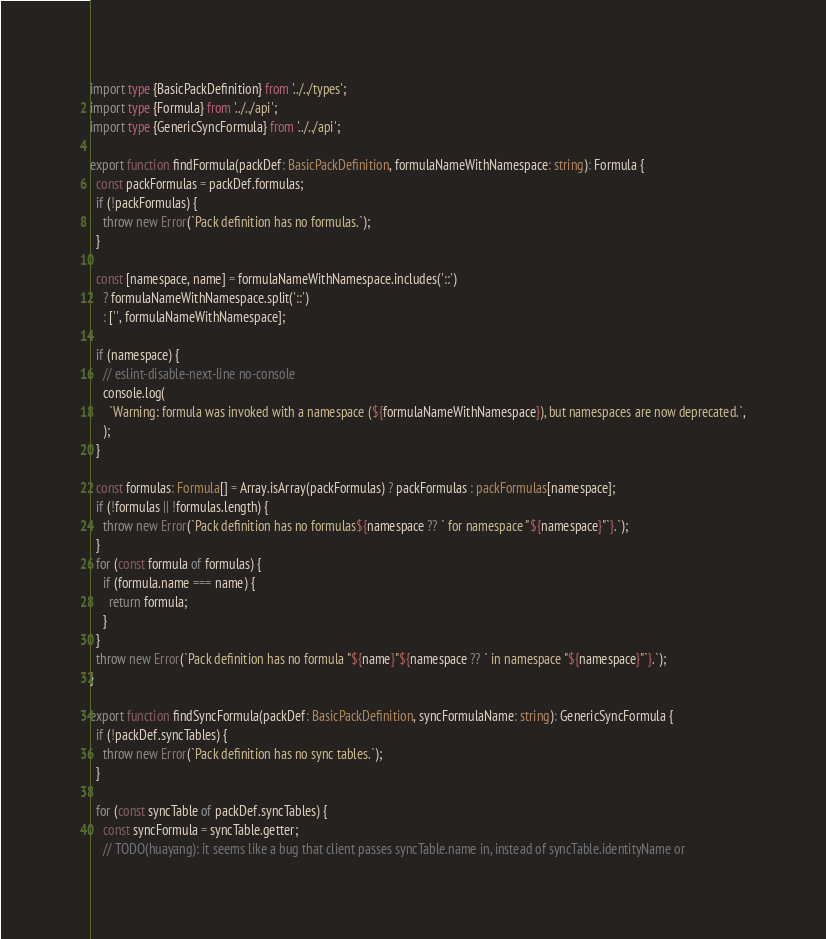Convert code to text. <code><loc_0><loc_0><loc_500><loc_500><_TypeScript_>import type {BasicPackDefinition} from '../../types';
import type {Formula} from '../../api';
import type {GenericSyncFormula} from '../../api';

export function findFormula(packDef: BasicPackDefinition, formulaNameWithNamespace: string): Formula {
  const packFormulas = packDef.formulas;
  if (!packFormulas) {
    throw new Error(`Pack definition has no formulas.`);
  }

  const [namespace, name] = formulaNameWithNamespace.includes('::')
    ? formulaNameWithNamespace.split('::')
    : ['', formulaNameWithNamespace];

  if (namespace) {
    // eslint-disable-next-line no-console
    console.log(
      `Warning: formula was invoked with a namespace (${formulaNameWithNamespace}), but namespaces are now deprecated.`,
    );
  }

  const formulas: Formula[] = Array.isArray(packFormulas) ? packFormulas : packFormulas[namespace];
  if (!formulas || !formulas.length) {
    throw new Error(`Pack definition has no formulas${namespace ?? ` for namespace "${namespace}"`}.`);
  }
  for (const formula of formulas) {
    if (formula.name === name) {
      return formula;
    }
  }
  throw new Error(`Pack definition has no formula "${name}"${namespace ?? ` in namespace "${namespace}"`}.`);
}

export function findSyncFormula(packDef: BasicPackDefinition, syncFormulaName: string): GenericSyncFormula {
  if (!packDef.syncTables) {
    throw new Error(`Pack definition has no sync tables.`);
  }

  for (const syncTable of packDef.syncTables) {
    const syncFormula = syncTable.getter;
    // TODO(huayang): it seems like a bug that client passes syncTable.name in, instead of syncTable.identityName or</code> 